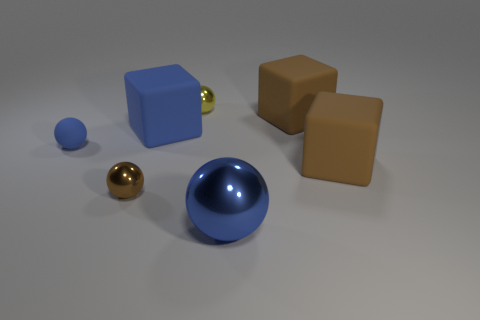There is a tiny shiny object to the right of the large blue matte object; what number of big brown rubber blocks are to the right of it?
Keep it short and to the point. 2. There is a tiny metal ball behind the big object on the left side of the big blue metallic object; what is its color?
Your response must be concise. Yellow. There is a big block that is behind the blue rubber ball and right of the yellow shiny thing; what material is it?
Offer a terse response. Rubber. Is there a small yellow thing that has the same shape as the brown metallic object?
Provide a succinct answer. Yes. There is a large thing that is in front of the brown ball; is its shape the same as the tiny matte thing?
Offer a terse response. Yes. How many balls are in front of the small blue sphere and to the left of the blue cube?
Offer a very short reply. 1. There is a large matte thing that is left of the small yellow shiny ball; what is its shape?
Ensure brevity in your answer.  Cube. How many other brown spheres are the same material as the large ball?
Ensure brevity in your answer.  1. There is a yellow shiny object; does it have the same shape as the large rubber object that is in front of the blue block?
Provide a succinct answer. No. Are there any large brown matte blocks that are on the right side of the big brown rubber thing in front of the matte cube that is on the left side of the blue metal ball?
Provide a succinct answer. No. 